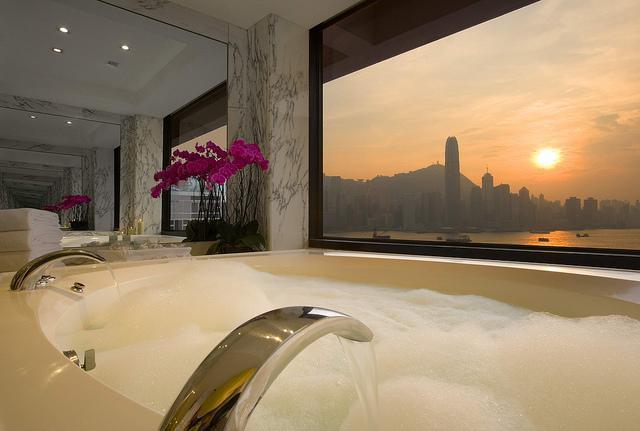How many motorcycles are here?
Give a very brief answer. 0. 